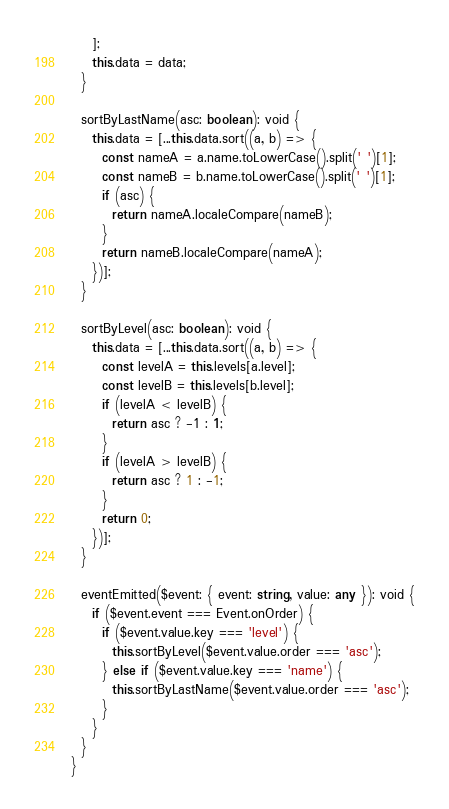Convert code to text. <code><loc_0><loc_0><loc_500><loc_500><_TypeScript_>    ];
    this.data = data;
  }

  sortByLastName(asc: boolean): void {
    this.data = [...this.data.sort((a, b) => {
      const nameA = a.name.toLowerCase().split(' ')[1];
      const nameB = b.name.toLowerCase().split(' ')[1];
      if (asc) {
        return nameA.localeCompare(nameB);
      }
      return nameB.localeCompare(nameA);
    })];
  }

  sortByLevel(asc: boolean): void {
    this.data = [...this.data.sort((a, b) => {
      const levelA = this.levels[a.level];
      const levelB = this.levels[b.level];
      if (levelA < levelB) {
        return asc ? -1 : 1;
      }
      if (levelA > levelB) {
        return asc ? 1 : -1;
      }
      return 0;
    })];
  }

  eventEmitted($event: { event: string, value: any }): void {
    if ($event.event === Event.onOrder) {
      if ($event.value.key === 'level') {
        this.sortByLevel($event.value.order === 'asc');
      } else if ($event.value.key === 'name') {
        this.sortByLastName($event.value.order === 'asc');
      }
    }
  }
}
</code> 